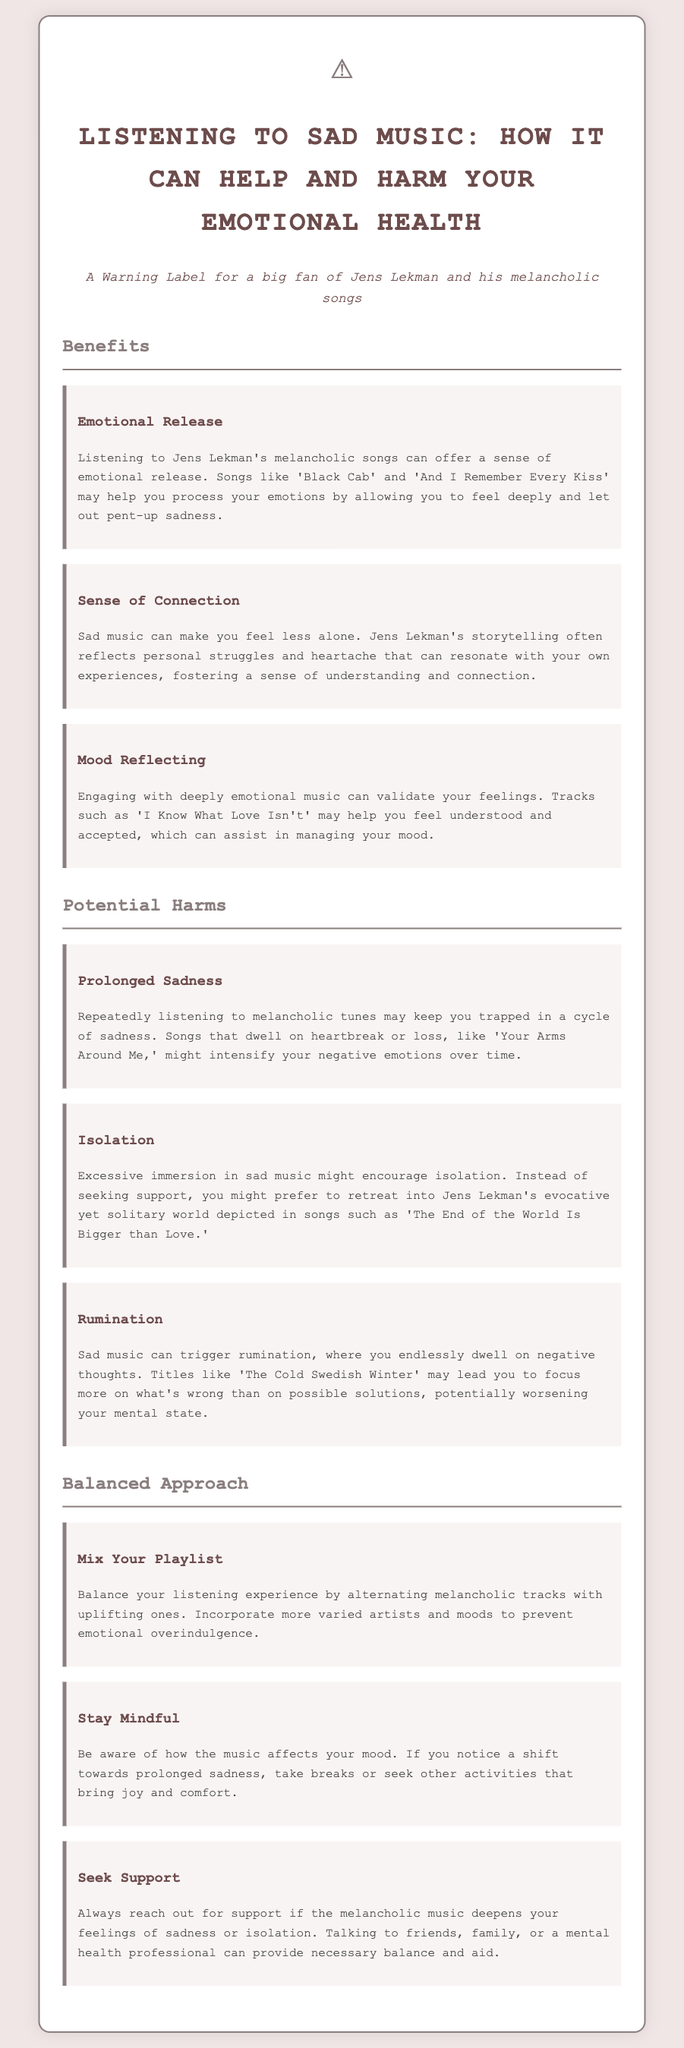what are the main benefits of listening to sad music? The document lists three benefits: Emotional Release, Sense of Connection, and Mood Reflecting.
Answer: Emotional Release, Sense of Connection, Mood Reflecting what can prolonged listening to sad music lead to? The document states that prolonged listening can lead to Prolonged Sadness.
Answer: Prolonged Sadness which song is mentioned as an example of emotional release? The document mentions 'Black Cab' as an example of emotional release.
Answer: Black Cab what does the document suggest for balancing your listening experience? It suggests mixing your playlist by alternating melancholic tracks with uplifting ones.
Answer: Mix Your Playlist what is a potential harm mentioned associated with sad music? The potential harms mentioned include Isolation.
Answer: Isolation what should you do if melancholic music deepens feelings of sadness? The document advises to seek support if feelings of sadness deepen.
Answer: Seek Support which Jens Lekman song relates to isolation? The song 'The End of the World Is Bigger than Love' relates to isolation.
Answer: The End of the World Is Bigger than Love what is the intended audience for this document? The document is specifically targeted towards a big fan of Jens Lekman and his melancholic songs.
Answer: A big fan of Jens Lekman and his melancholic songs how many sections are there in the document? There are three main sections: Benefits, Potential Harms, and Balanced Approach.
Answer: Three 